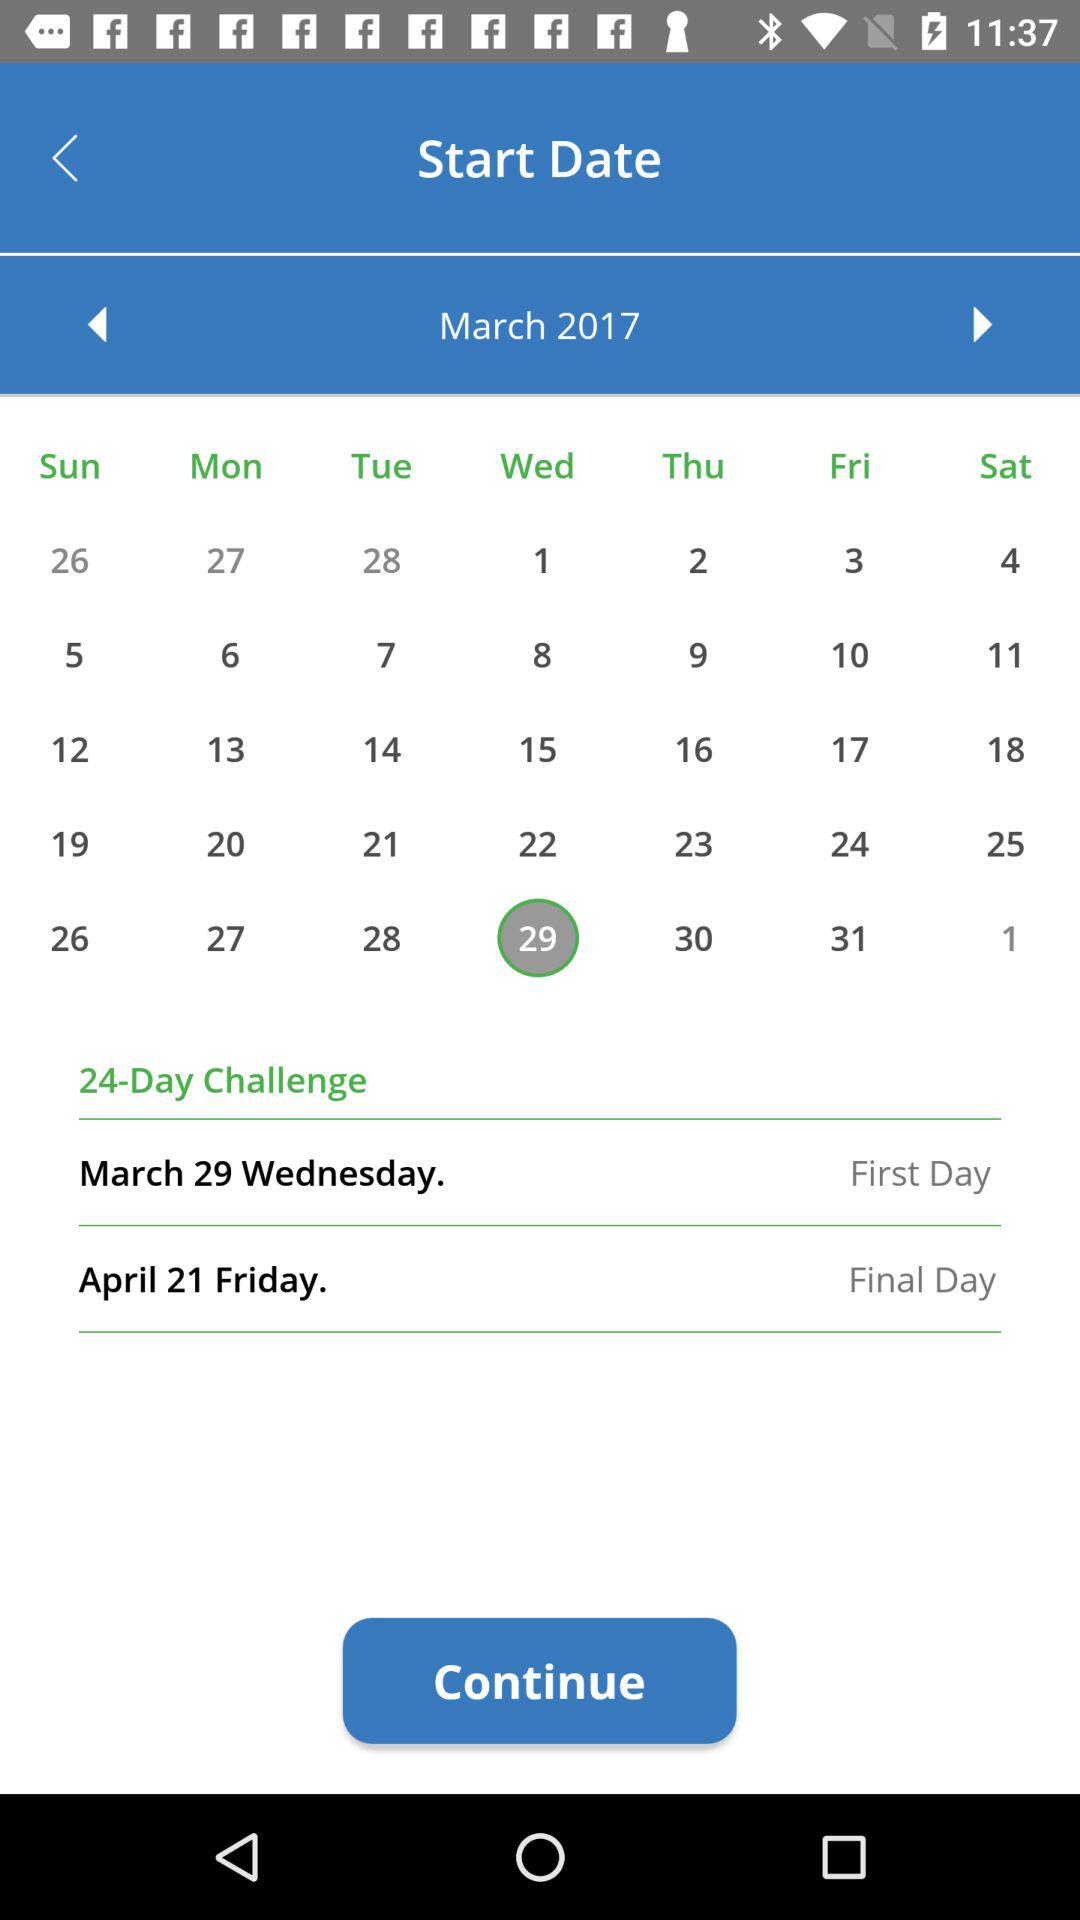What is the first day? The first day is March 29th, Wednesday. 